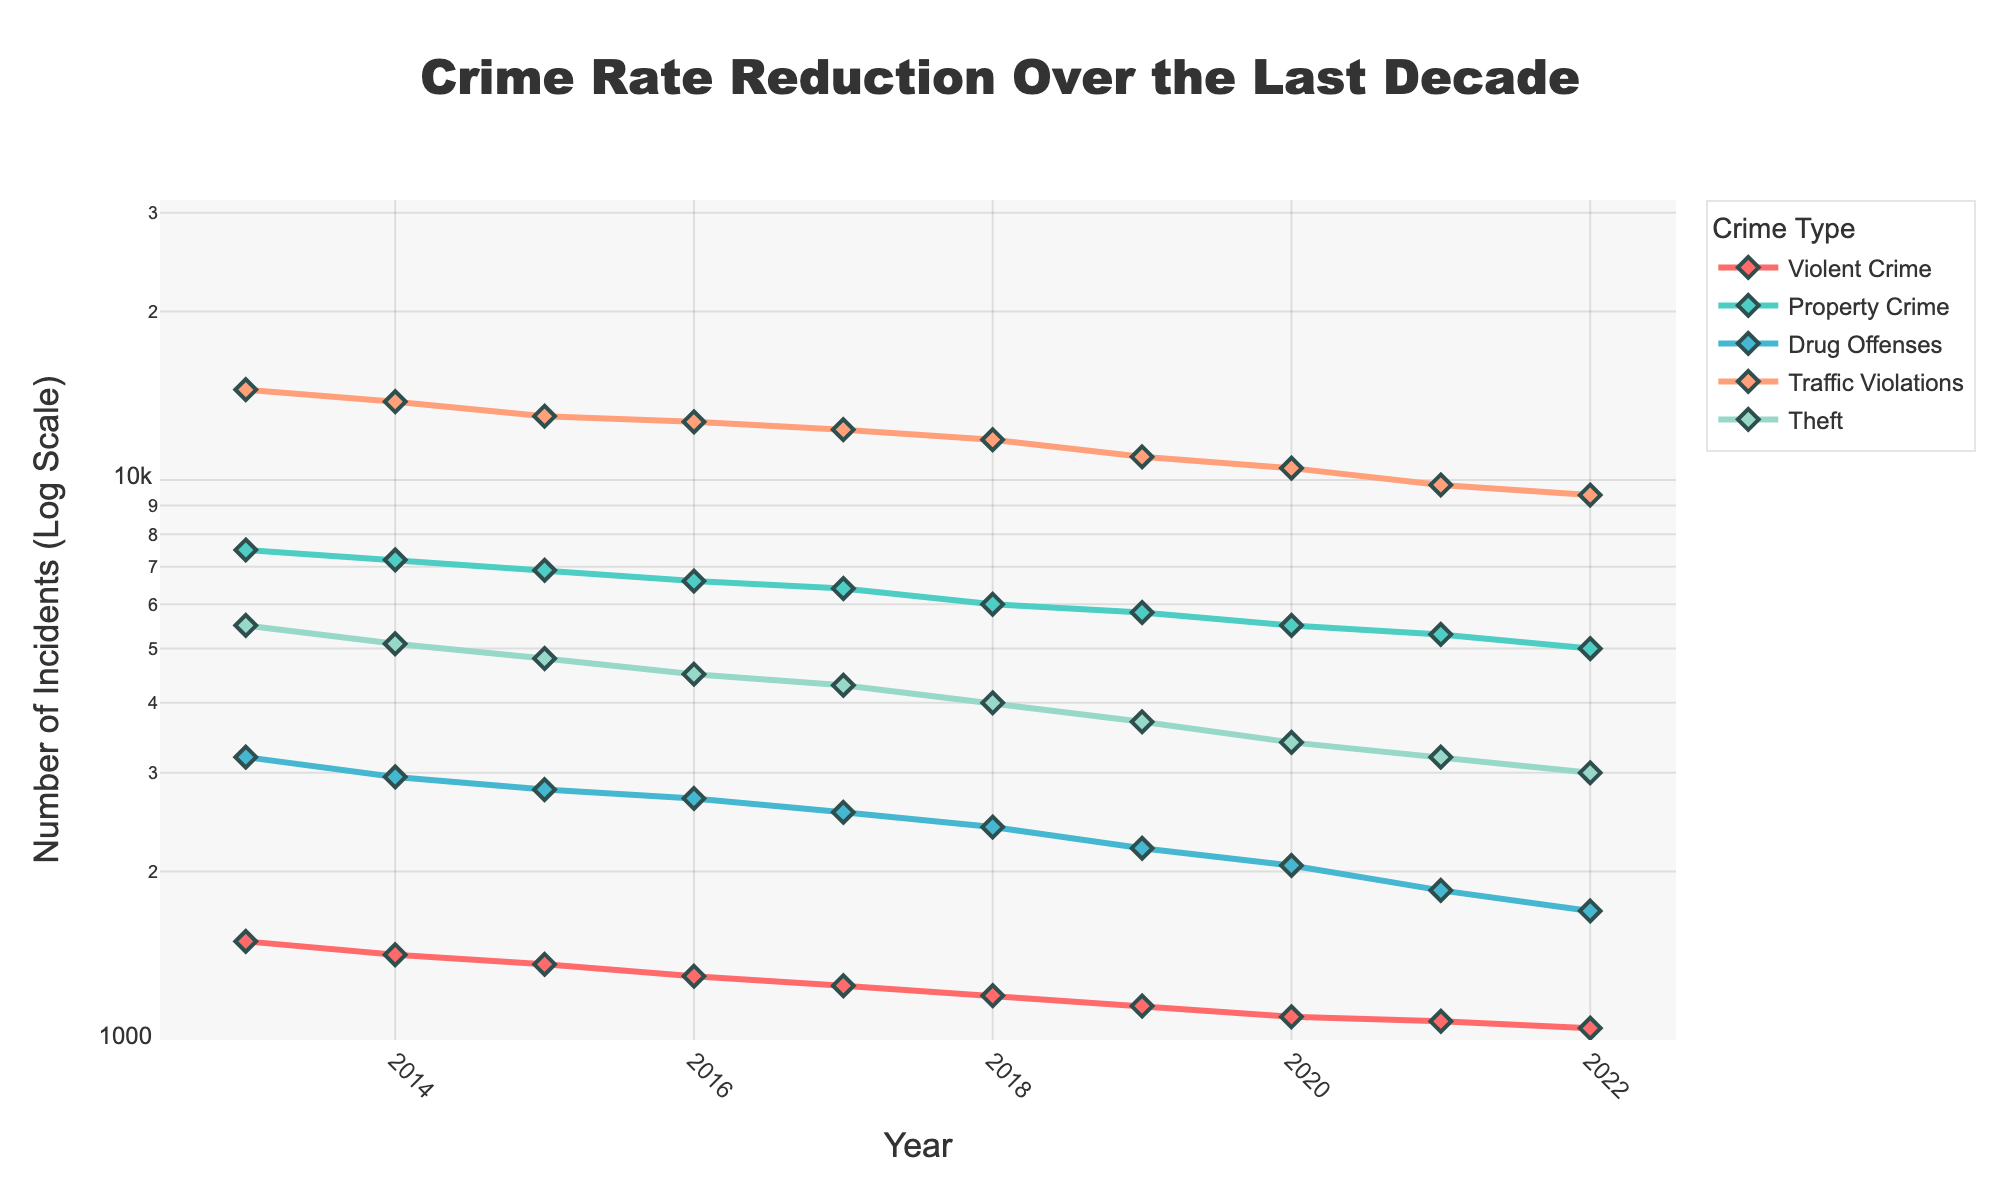What's the title of the plot? The title of the plot is centrally positioned at the top of the figure.
Answer: Crime Rate Reduction Over the Last Decade What does the y-axis represent? The y-axis represents the number of incidents on a log scale.
Answer: Number of Incidents (Log Scale) Which crime type had the highest count in 2022? By tracing the highest data point for the year 2022, Traffic Violations had the highest count.
Answer: Traffic Violations How many different crime types are shown in the plot? By counting the unique legend entries, there are five different crime types shown.
Answer: Five Compare the trend of Violent Crime and Property Crime over the last decade. Which one declined more steeply? Observing the lines representing Violent Crime and Property Crime, Violent Crime shows a steeper decline over the given period.
Answer: Violent Crime From 2013 to 2022, which crime type shows the smallest reduction? By comparing the difference in the heights of the data points for the years 2013 and 2022 for each crime type, Traffic Violations show the smallest reduction.
Answer: Traffic Violations What is the range of the y-axis? The range of the y-axis starts from a log-scale of 3 (1000) to about 4.5 (approximately 31600).
Answer: 3 to 4.5 Calculate the average count of Drug Offenses from 2013 to 2022. Sum the yearly counts of Drug Offenses from 2013 to 2022 and divide by the number of years (10). (3200 + 2950 + 2800 + 2700 + 2550 + 2400 + 2200 + 2050 + 1850 + 1700) / 10 = 2440
Answer: 2440 In which year did Theft see the most significant drop from the previous year? By observing the steepest drop in the lines representing Theft between consecutive years, the drop from 2018 to 2019 is the most significant.
Answer: 2018 to 2019 